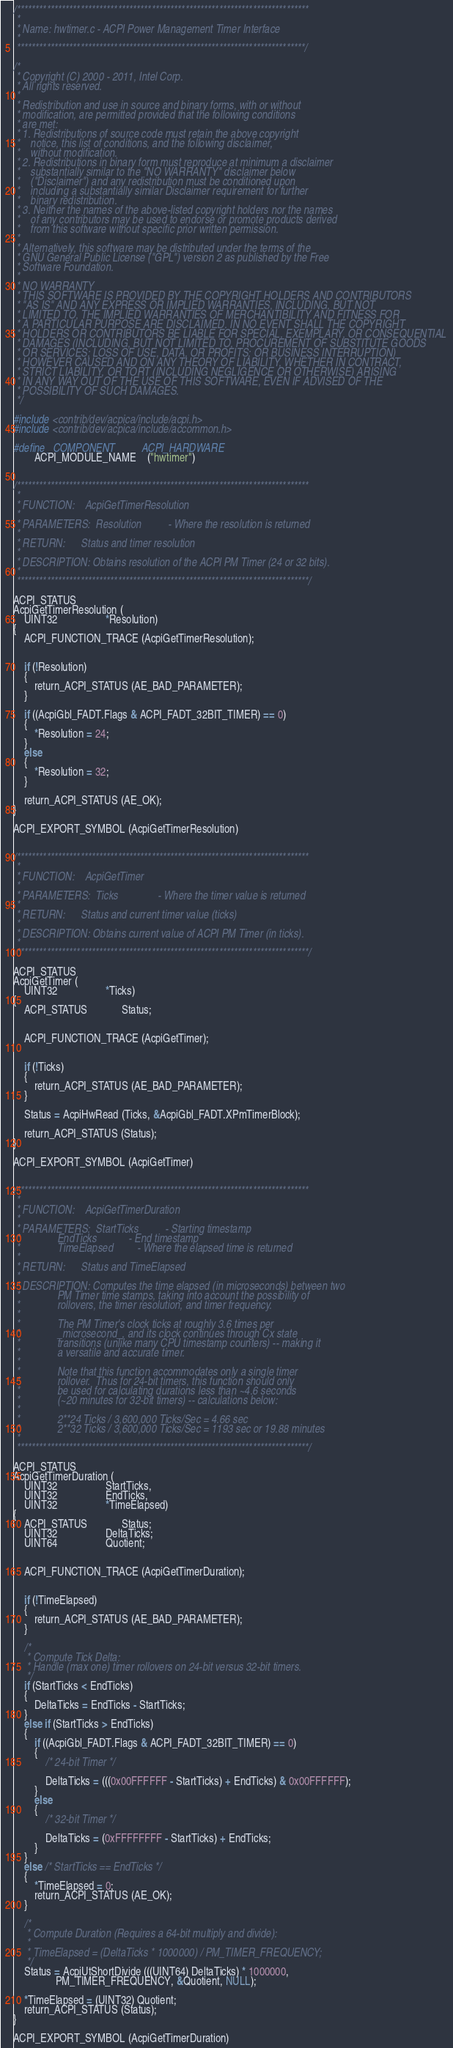Convert code to text. <code><loc_0><loc_0><loc_500><loc_500><_C_>
/******************************************************************************
 *
 * Name: hwtimer.c - ACPI Power Management Timer Interface
 *
 *****************************************************************************/

/*
 * Copyright (C) 2000 - 2011, Intel Corp.
 * All rights reserved.
 *
 * Redistribution and use in source and binary forms, with or without
 * modification, are permitted provided that the following conditions
 * are met:
 * 1. Redistributions of source code must retain the above copyright
 *    notice, this list of conditions, and the following disclaimer,
 *    without modification.
 * 2. Redistributions in binary form must reproduce at minimum a disclaimer
 *    substantially similar to the "NO WARRANTY" disclaimer below
 *    ("Disclaimer") and any redistribution must be conditioned upon
 *    including a substantially similar Disclaimer requirement for further
 *    binary redistribution.
 * 3. Neither the names of the above-listed copyright holders nor the names
 *    of any contributors may be used to endorse or promote products derived
 *    from this software without specific prior written permission.
 *
 * Alternatively, this software may be distributed under the terms of the
 * GNU General Public License ("GPL") version 2 as published by the Free
 * Software Foundation.
 *
 * NO WARRANTY
 * THIS SOFTWARE IS PROVIDED BY THE COPYRIGHT HOLDERS AND CONTRIBUTORS
 * "AS IS" AND ANY EXPRESS OR IMPLIED WARRANTIES, INCLUDING, BUT NOT
 * LIMITED TO, THE IMPLIED WARRANTIES OF MERCHANTIBILITY AND FITNESS FOR
 * A PARTICULAR PURPOSE ARE DISCLAIMED. IN NO EVENT SHALL THE COPYRIGHT
 * HOLDERS OR CONTRIBUTORS BE LIABLE FOR SPECIAL, EXEMPLARY, OR CONSEQUENTIAL
 * DAMAGES (INCLUDING, BUT NOT LIMITED TO, PROCUREMENT OF SUBSTITUTE GOODS
 * OR SERVICES; LOSS OF USE, DATA, OR PROFITS; OR BUSINESS INTERRUPTION)
 * HOWEVER CAUSED AND ON ANY THEORY OF LIABILITY, WHETHER IN CONTRACT,
 * STRICT LIABILITY, OR TORT (INCLUDING NEGLIGENCE OR OTHERWISE) ARISING
 * IN ANY WAY OUT OF THE USE OF THIS SOFTWARE, EVEN IF ADVISED OF THE
 * POSSIBILITY OF SUCH DAMAGES.
 */

#include <contrib/dev/acpica/include/acpi.h>
#include <contrib/dev/acpica/include/accommon.h>

#define _COMPONENT          ACPI_HARDWARE
        ACPI_MODULE_NAME    ("hwtimer")


/******************************************************************************
 *
 * FUNCTION:    AcpiGetTimerResolution
 *
 * PARAMETERS:  Resolution          - Where the resolution is returned
 *
 * RETURN:      Status and timer resolution
 *
 * DESCRIPTION: Obtains resolution of the ACPI PM Timer (24 or 32 bits).
 *
 ******************************************************************************/

ACPI_STATUS
AcpiGetTimerResolution (
    UINT32                  *Resolution)
{
    ACPI_FUNCTION_TRACE (AcpiGetTimerResolution);


    if (!Resolution)
    {
        return_ACPI_STATUS (AE_BAD_PARAMETER);
    }

    if ((AcpiGbl_FADT.Flags & ACPI_FADT_32BIT_TIMER) == 0)
    {
        *Resolution = 24;
    }
    else
    {
        *Resolution = 32;
    }

    return_ACPI_STATUS (AE_OK);
}

ACPI_EXPORT_SYMBOL (AcpiGetTimerResolution)


/******************************************************************************
 *
 * FUNCTION:    AcpiGetTimer
 *
 * PARAMETERS:  Ticks               - Where the timer value is returned
 *
 * RETURN:      Status and current timer value (ticks)
 *
 * DESCRIPTION: Obtains current value of ACPI PM Timer (in ticks).
 *
 ******************************************************************************/

ACPI_STATUS
AcpiGetTimer (
    UINT32                  *Ticks)
{
    ACPI_STATUS             Status;


    ACPI_FUNCTION_TRACE (AcpiGetTimer);


    if (!Ticks)
    {
        return_ACPI_STATUS (AE_BAD_PARAMETER);
    }

    Status = AcpiHwRead (Ticks, &AcpiGbl_FADT.XPmTimerBlock);

    return_ACPI_STATUS (Status);
}

ACPI_EXPORT_SYMBOL (AcpiGetTimer)


/******************************************************************************
 *
 * FUNCTION:    AcpiGetTimerDuration
 *
 * PARAMETERS:  StartTicks          - Starting timestamp
 *              EndTicks            - End timestamp
 *              TimeElapsed         - Where the elapsed time is returned
 *
 * RETURN:      Status and TimeElapsed
 *
 * DESCRIPTION: Computes the time elapsed (in microseconds) between two
 *              PM Timer time stamps, taking into account the possibility of
 *              rollovers, the timer resolution, and timer frequency.
 *
 *              The PM Timer's clock ticks at roughly 3.6 times per
 *              _microsecond_, and its clock continues through Cx state
 *              transitions (unlike many CPU timestamp counters) -- making it
 *              a versatile and accurate timer.
 *
 *              Note that this function accommodates only a single timer
 *              rollover.  Thus for 24-bit timers, this function should only
 *              be used for calculating durations less than ~4.6 seconds
 *              (~20 minutes for 32-bit timers) -- calculations below:
 *
 *              2**24 Ticks / 3,600,000 Ticks/Sec = 4.66 sec
 *              2**32 Ticks / 3,600,000 Ticks/Sec = 1193 sec or 19.88 minutes
 *
 ******************************************************************************/

ACPI_STATUS
AcpiGetTimerDuration (
    UINT32                  StartTicks,
    UINT32                  EndTicks,
    UINT32                  *TimeElapsed)
{
    ACPI_STATUS             Status;
    UINT32                  DeltaTicks;
    UINT64                  Quotient;


    ACPI_FUNCTION_TRACE (AcpiGetTimerDuration);


    if (!TimeElapsed)
    {
        return_ACPI_STATUS (AE_BAD_PARAMETER);
    }

    /*
     * Compute Tick Delta:
     * Handle (max one) timer rollovers on 24-bit versus 32-bit timers.
     */
    if (StartTicks < EndTicks)
    {
        DeltaTicks = EndTicks - StartTicks;
    }
    else if (StartTicks > EndTicks)
    {
        if ((AcpiGbl_FADT.Flags & ACPI_FADT_32BIT_TIMER) == 0)
        {
            /* 24-bit Timer */

            DeltaTicks = (((0x00FFFFFF - StartTicks) + EndTicks) & 0x00FFFFFF);
        }
        else
        {
            /* 32-bit Timer */

            DeltaTicks = (0xFFFFFFFF - StartTicks) + EndTicks;
        }
    }
    else /* StartTicks == EndTicks */
    {
        *TimeElapsed = 0;
        return_ACPI_STATUS (AE_OK);
    }

    /*
     * Compute Duration (Requires a 64-bit multiply and divide):
     *
     * TimeElapsed = (DeltaTicks * 1000000) / PM_TIMER_FREQUENCY;
     */
    Status = AcpiUtShortDivide (((UINT64) DeltaTicks) * 1000000,
                PM_TIMER_FREQUENCY, &Quotient, NULL);

    *TimeElapsed = (UINT32) Quotient;
    return_ACPI_STATUS (Status);
}

ACPI_EXPORT_SYMBOL (AcpiGetTimerDuration)

</code> 